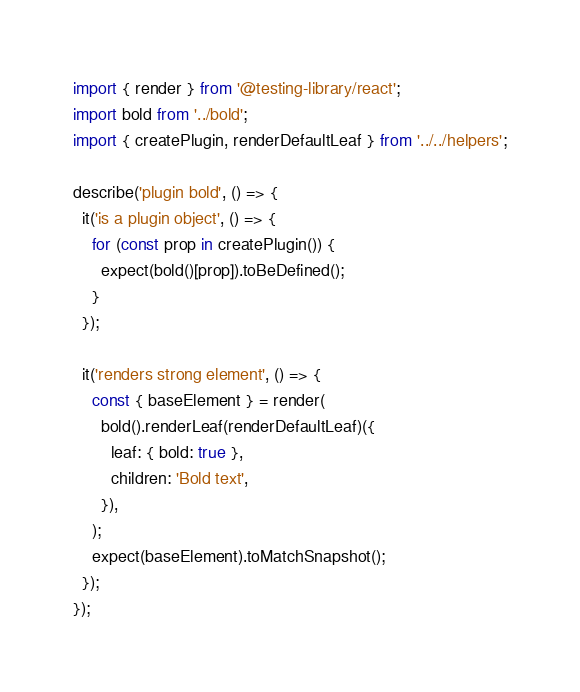Convert code to text. <code><loc_0><loc_0><loc_500><loc_500><_JavaScript_>import { render } from '@testing-library/react';
import bold from '../bold';
import { createPlugin, renderDefaultLeaf } from '../../helpers';

describe('plugin bold', () => {
  it('is a plugin object', () => {
    for (const prop in createPlugin()) {
      expect(bold()[prop]).toBeDefined();
    }
  });

  it('renders strong element', () => {
    const { baseElement } = render(
      bold().renderLeaf(renderDefaultLeaf)({
        leaf: { bold: true },
        children: 'Bold text',
      }),
    );
    expect(baseElement).toMatchSnapshot();
  });
});
</code> 